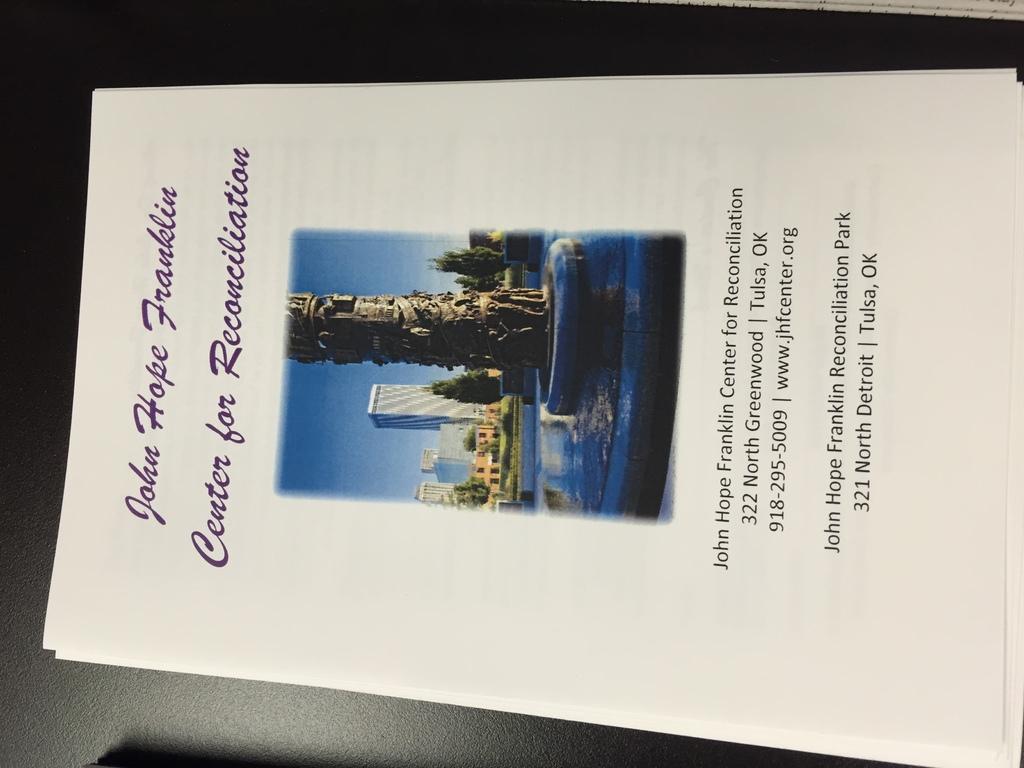Where is the reconciliation park located?
Your answer should be very brief. Tulsa, ok. 